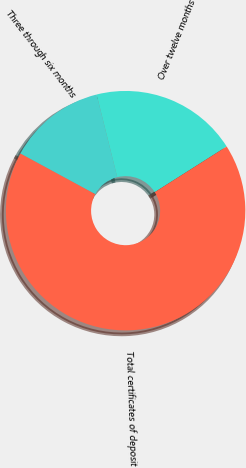Convert chart. <chart><loc_0><loc_0><loc_500><loc_500><pie_chart><fcel>Three through six months<fcel>Over twelve months<fcel>Total certificates of deposit<nl><fcel>13.2%<fcel>19.89%<fcel>66.91%<nl></chart> 